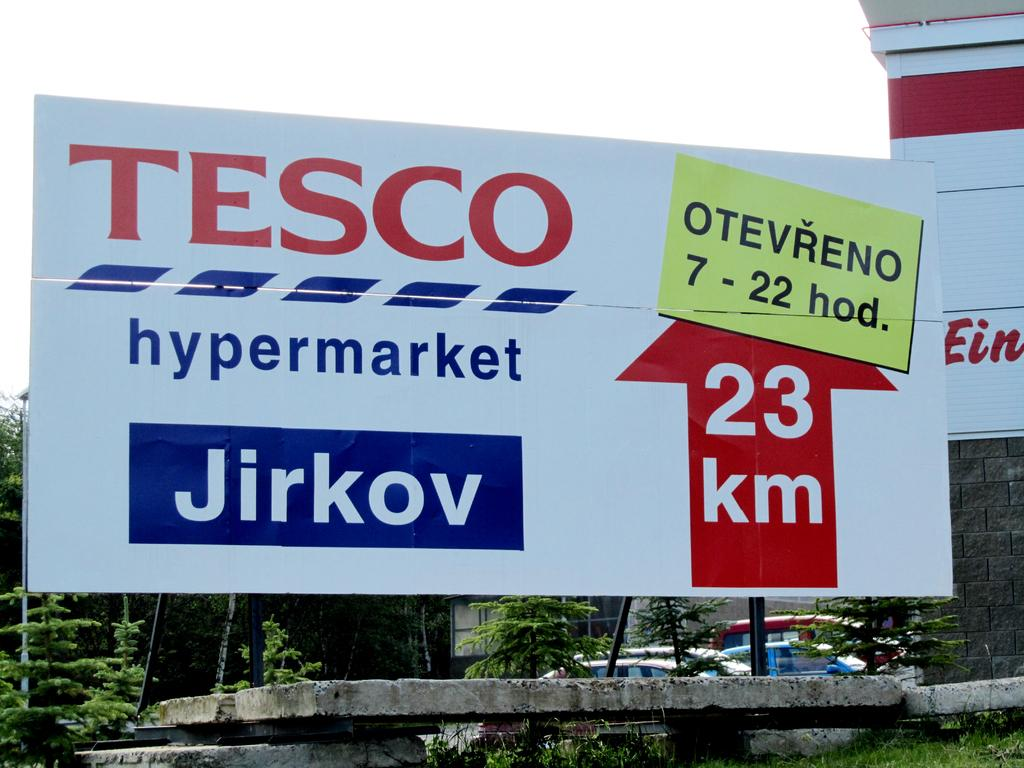Provide a one-sentence caption for the provided image. A billboard from tesco that says 23 km ahead. 